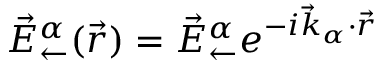<formula> <loc_0><loc_0><loc_500><loc_500>\vec { E } _ { \leftarrow } ^ { \alpha } ( \vec { r } ) = \vec { E } _ { \leftarrow } ^ { \alpha } e ^ { - i \vec { k } _ { \alpha } \cdot \vec { r } }</formula> 